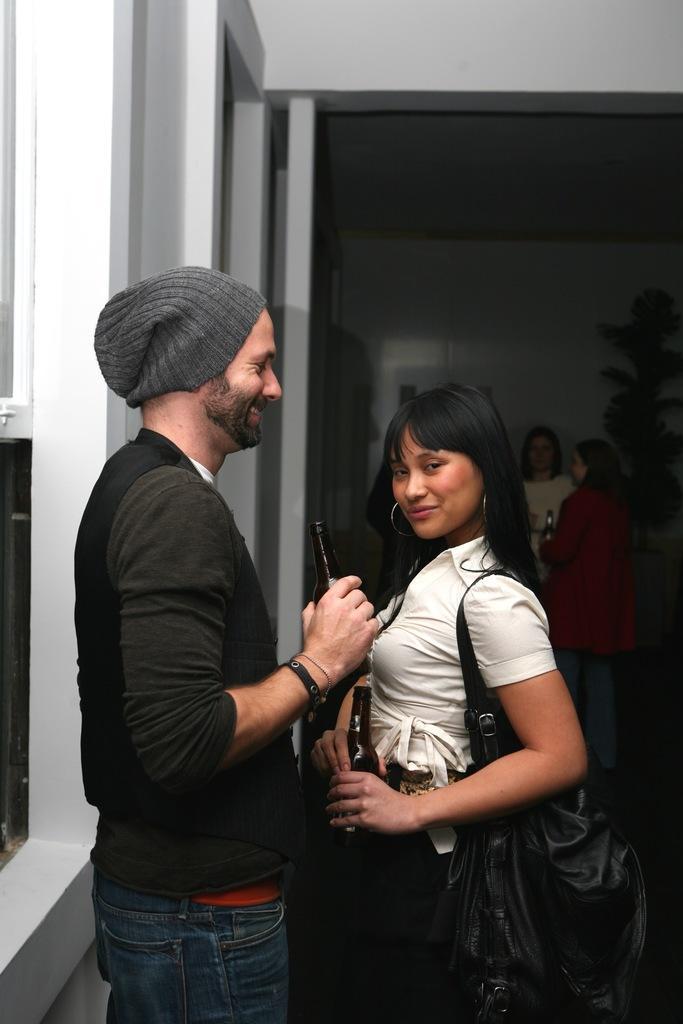Could you give a brief overview of what you see in this image? This picture is clicked inside the room. The man in black T-shirt is holding a glass bottle in his hands. He is smiling. In front of him, the girl in white dress is also holding a glass bottle in her hands. Behind them, we see two women are standing. Behind them, we see a wall in white color. On the left side, we see a white wall and a window. 